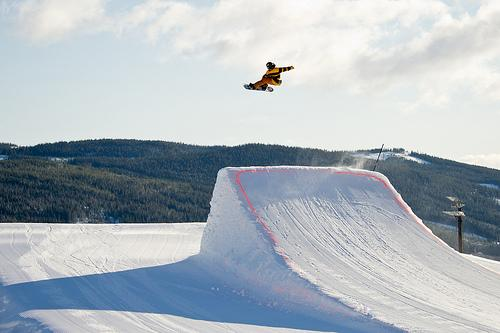Count the number of distinct objects in the image related to the main subject. There are 7 distinct objects related to the snowboarder: the snowboard, snow ramp, jacket, snow dust, extended arm, shadow, and airborne position. What is the general emotion or sentiment conveyed by this image? The image conveys a sense of excitement and adventure as the snowboarder performs a thrilling trick. What color is the snowboarder's jacket and what is he doing in the image? The snowboarder is wearing a yellow and black jacket and performing a trick in mid-air. What are the various objects and elements present in the image that contribute to a winter sport scene? The snowboarder, large snow ramp, snow-covered ground, and snow dust above the ramp contribute to the winter sport scene. Perform a complex reasoning task by inferring the type of event taking place based on the evidence present in the image. Based on the snowboarder performing a trick in mid-air over a snow ramp, the event taking place is likely a snowboarding competition or exhibition. How many clouds can you count in the blue sky? There are 9 patches of white clouds in the blue sky. Analyze the interaction between the snowboarder and the snow ramp in the image. The snowboarder is airborne above the snow ramp, having likely used the ramp's slope to launch into the air to perform a trick. Assess the quality of the image and whether it is clear or blurry, bright or dark. The image is of high quality, with clear objects and a well-lit, brightly colored scene. Identify the primary action happening in the image and the object involved in it. A snowboarder is performing a trick in the air above a ramp made of snow. Give a brief description of the scene visible in the image. The image shows a snowboarder in the air above a snow ramp, with a tree-covered hillside in the background, and a cloudy blue sky above. Select the correct description for the image's background. A) A sunny beach with palm trees B) A cloudy sky above a tree-covered hillside C) An urban cityscape with tall buildings B) A cloudy sky above a tree-covered hillside Describe the weather and environment in the background of the image. A cloudy grey sky with patches of white clouds, complemented by a hillside covered with trees. Is there a large snow ramp made of sand in the image? This is misleading because the ramp is made of snow, not sand. In your own words, describe the scene in the image. A snowboarder in a yellow and black jacket is airborne above a snow ramp, performing a trick with an extended arm. The background features a cloudy sky and a hillside covered with trees. Can you locate the clear, blue sky without any clouds? This is misleading because the sky in the image is described as "cloudy grey" or "blue with white clouds," not clear and without clouds. Could you spot the cars driving on a nearby road? No, it's not mentioned in the image. What is the shape of the snow-covered area on the ground? The snow-covered area on the ground cannot be accurately determined from the given information. Are there any shadows visible in the image? Yes, there is a shadow on the left side of the ramp. Can you find the snowboarder wearing a green jacket and doing a trick in the air? This is misleading because the snowboarder is actually wearing a yellow and black jacket, not a green one. What is the main activity happening in the image? A person is snowboarding and doing a trick in the air. How would you describe the terrain in the image? A snowy terrain with tree-covered hillsides and a snow ramp. Identify the surface that the snowboarder is above. A snow-covered ramp Is the snowboarder wearing a brightly colored jacket? Yes, the snowboarder is wearing a yellow and black jacket. Predict the snowboarder's current action based on the given information. The snowboarder is likely executing a trick while being airborne above the snow ramp. What color is the sky in the image? Grey with blue sections and white clouds What are the most prominent objects in this image? A snowboarder in the air, a snow ramp, a yellow and black jacket, and a tree-covered hillside. What type of objects can you see the sky and the ground? Cloudy sky, patches of white clouds, hills covered with trees, and ground covered in snow. Find the snowboarder with both feet on the ground. This is misleading because the snowboarder in the image is in the air, not standing on the ground. Write a descriptive sentence about the snowboarder's attire. The snowboarder is wearing a yellow and black jacket and is riding a large snowboard. Where can you see patches of snow in the image? There are patches of snow among the trees on the hillside. What type of surface is the ramp made of? The ramp is made of snow. Is there any snow dust visible in the image? Yes, there is snow dust above the ramp. Where are the palm trees on the hillside? This is misleading because the hillside is described as being covered with trees, but there is no mention of palm trees specifically. What type of ramp is the snowboarder performing the trick on? A snow ramp 